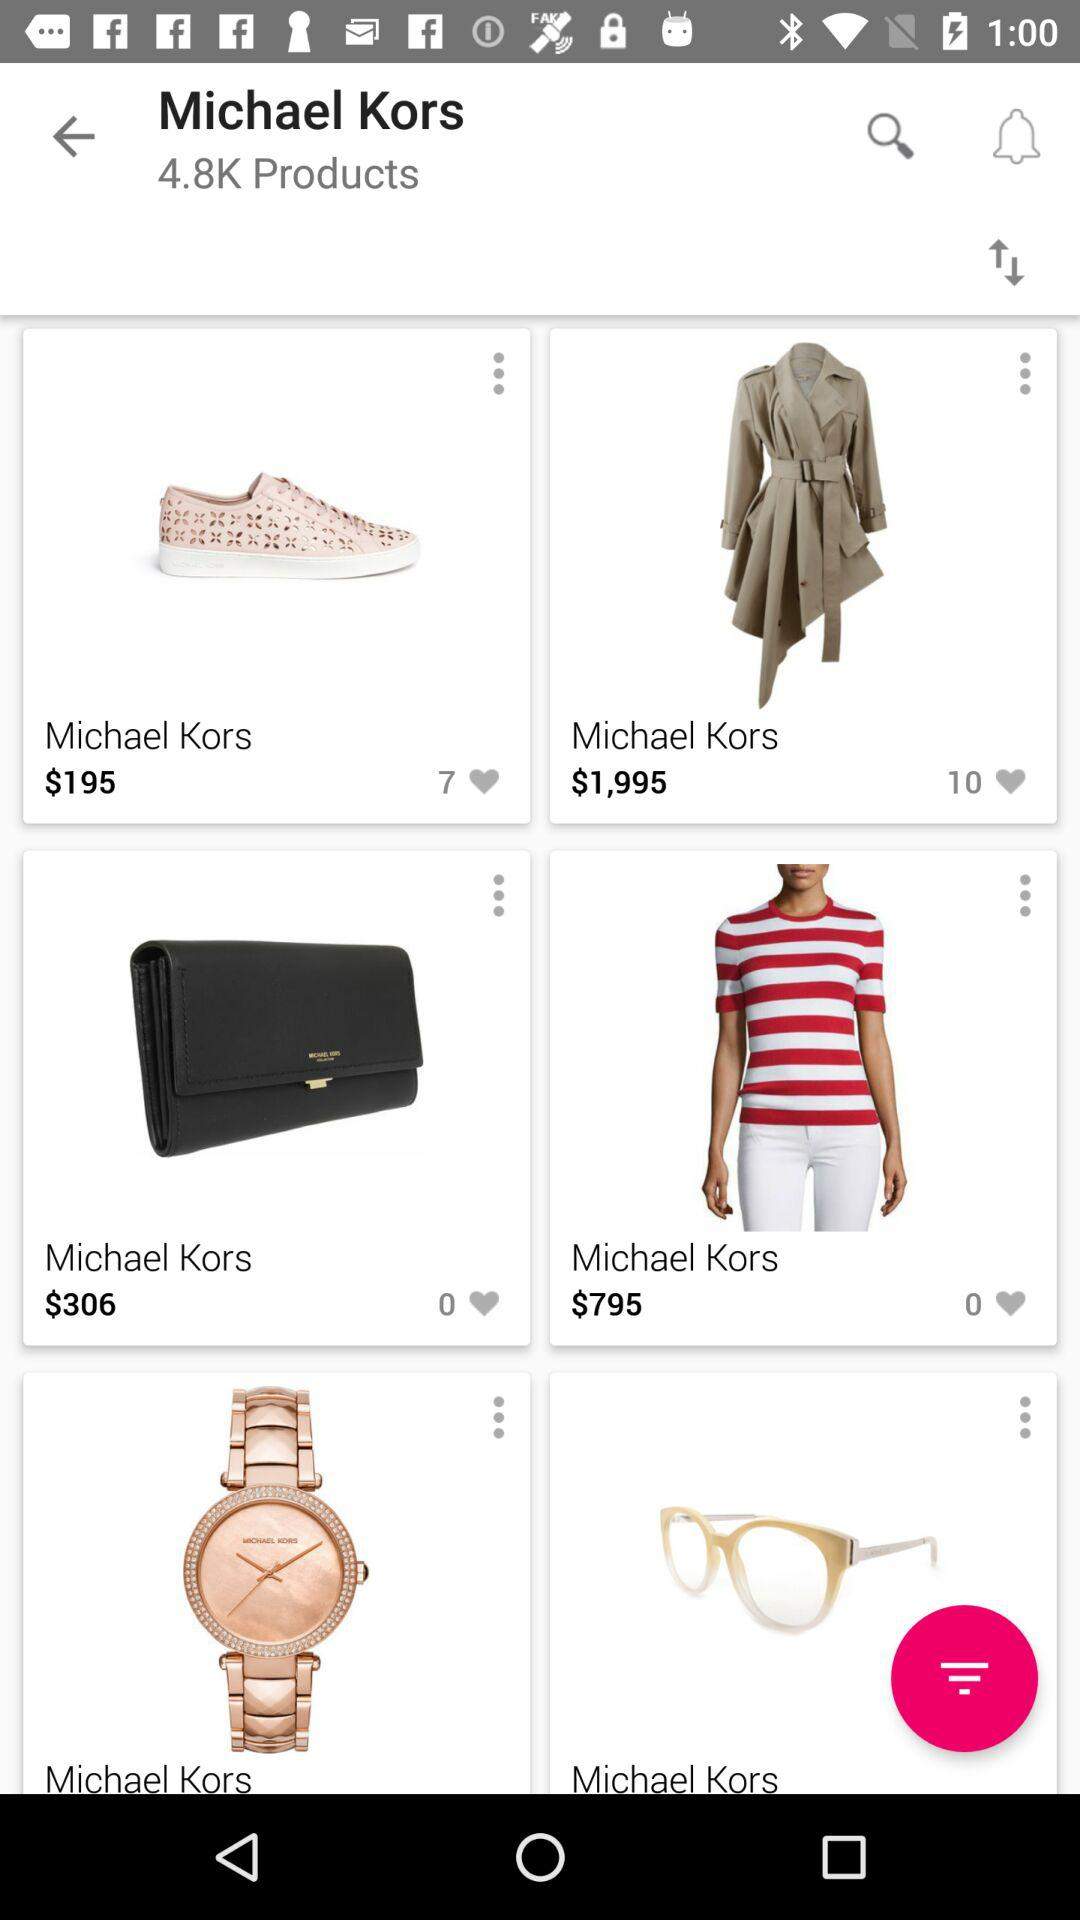How many likes for a coat? There are 10 likes for a coat. 